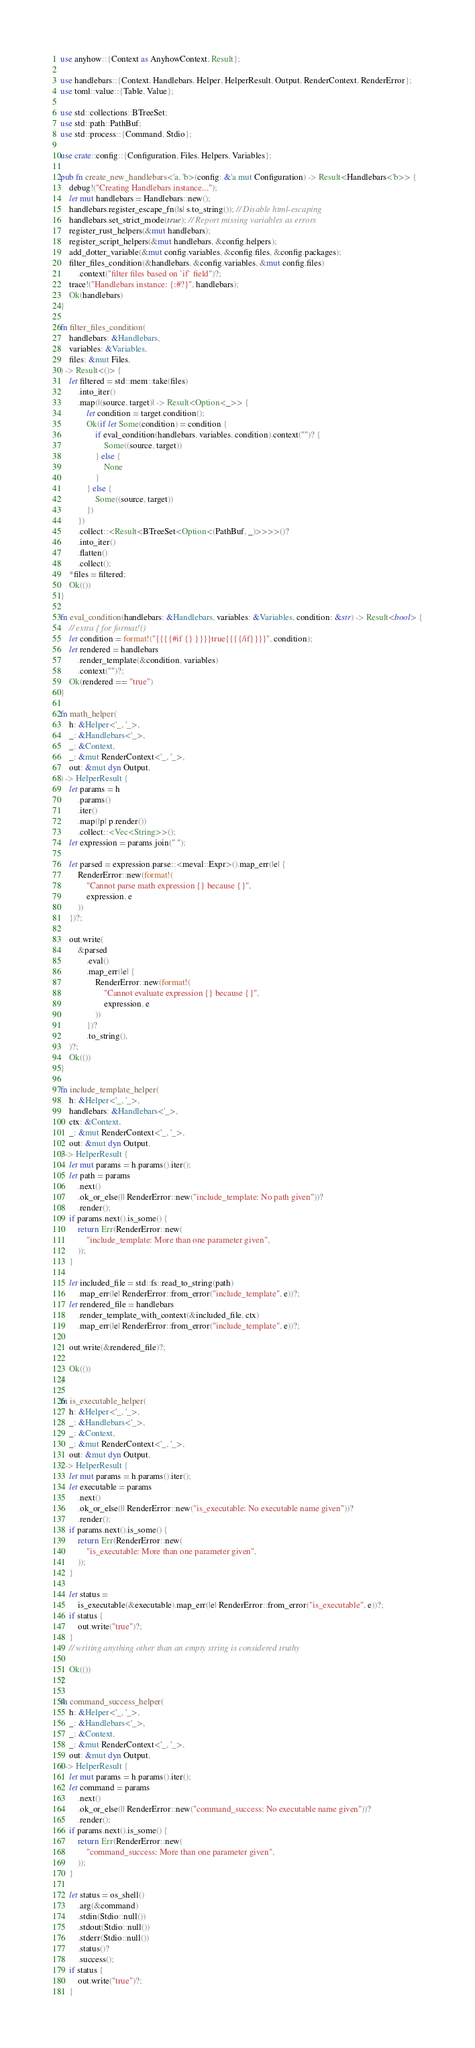<code> <loc_0><loc_0><loc_500><loc_500><_Rust_>use anyhow::{Context as AnyhowContext, Result};

use handlebars::{Context, Handlebars, Helper, HelperResult, Output, RenderContext, RenderError};
use toml::value::{Table, Value};

use std::collections::BTreeSet;
use std::path::PathBuf;
use std::process::{Command, Stdio};

use crate::config::{Configuration, Files, Helpers, Variables};

pub fn create_new_handlebars<'a, 'b>(config: &'a mut Configuration) -> Result<Handlebars<'b>> {
    debug!("Creating Handlebars instance...");
    let mut handlebars = Handlebars::new();
    handlebars.register_escape_fn(|s| s.to_string()); // Disable html-escaping
    handlebars.set_strict_mode(true); // Report missing variables as errors
    register_rust_helpers(&mut handlebars);
    register_script_helpers(&mut handlebars, &config.helpers);
    add_dotter_variable(&mut config.variables, &config.files, &config.packages);
    filter_files_condition(&handlebars, &config.variables, &mut config.files)
        .context("filter files based on `if` field")?;
    trace!("Handlebars instance: {:#?}", handlebars);
    Ok(handlebars)
}

fn filter_files_condition(
    handlebars: &Handlebars,
    variables: &Variables,
    files: &mut Files,
) -> Result<()> {
    let filtered = std::mem::take(files)
        .into_iter()
        .map(|(source, target)| -> Result<Option<_>> {
            let condition = target.condition();
            Ok(if let Some(condition) = condition {
                if eval_condition(handlebars, variables, condition).context("")? {
                    Some((source, target))
                } else {
                    None
                }
            } else {
                Some((source, target))
            })
        })
        .collect::<Result<BTreeSet<Option<(PathBuf, _)>>>>()?
        .into_iter()
        .flatten()
        .collect();
    *files = filtered;
    Ok(())
}

fn eval_condition(handlebars: &Handlebars, variables: &Variables, condition: &str) -> Result<bool> {
    // extra { for format!()
    let condition = format!("{{{{#if {} }}}}true{{{{/if}}}}", condition);
    let rendered = handlebars
        .render_template(&condition, variables)
        .context("")?;
    Ok(rendered == "true")
}

fn math_helper(
    h: &Helper<'_, '_>,
    _: &Handlebars<'_>,
    _: &Context,
    _: &mut RenderContext<'_, '_>,
    out: &mut dyn Output,
) -> HelperResult {
    let params = h
        .params()
        .iter()
        .map(|p| p.render())
        .collect::<Vec<String>>();
    let expression = params.join(" ");

    let parsed = expression.parse::<meval::Expr>().map_err(|e| {
        RenderError::new(format!(
            "Cannot parse math expression {} because {}",
            expression, e
        ))
    })?;

    out.write(
        &parsed
            .eval()
            .map_err(|e| {
                RenderError::new(format!(
                    "Cannot evaluate expression {} because {}",
                    expression, e
                ))
            })?
            .to_string(),
    )?;
    Ok(())
}

fn include_template_helper(
    h: &Helper<'_, '_>,
    handlebars: &Handlebars<'_>,
    ctx: &Context,
    _: &mut RenderContext<'_, '_>,
    out: &mut dyn Output,
) -> HelperResult {
    let mut params = h.params().iter();
    let path = params
        .next()
        .ok_or_else(|| RenderError::new("include_template: No path given"))?
        .render();
    if params.next().is_some() {
        return Err(RenderError::new(
            "include_template: More than one parameter given",
        ));
    }

    let included_file = std::fs::read_to_string(path)
        .map_err(|e| RenderError::from_error("include_template", e))?;
    let rendered_file = handlebars
        .render_template_with_context(&included_file, ctx)
        .map_err(|e| RenderError::from_error("include_template", e))?;

    out.write(&rendered_file)?;

    Ok(())
}

fn is_executable_helper(
    h: &Helper<'_, '_>,
    _: &Handlebars<'_>,
    _: &Context,
    _: &mut RenderContext<'_, '_>,
    out: &mut dyn Output,
) -> HelperResult {
    let mut params = h.params().iter();
    let executable = params
        .next()
        .ok_or_else(|| RenderError::new("is_executable: No executable name given"))?
        .render();
    if params.next().is_some() {
        return Err(RenderError::new(
            "is_executable: More than one parameter given",
        ));
    }

    let status =
        is_executable(&executable).map_err(|e| RenderError::from_error("is_executable", e))?;
    if status {
        out.write("true")?;
    }
    // writing anything other than an empty string is considered truthy

    Ok(())
}

fn command_success_helper(
    h: &Helper<'_, '_>,
    _: &Handlebars<'_>,
    _: &Context,
    _: &mut RenderContext<'_, '_>,
    out: &mut dyn Output,
) -> HelperResult {
    let mut params = h.params().iter();
    let command = params
        .next()
        .ok_or_else(|| RenderError::new("command_success: No executable name given"))?
        .render();
    if params.next().is_some() {
        return Err(RenderError::new(
            "command_success: More than one parameter given",
        ));
    }

    let status = os_shell()
        .arg(&command)
        .stdin(Stdio::null())
        .stdout(Stdio::null())
        .stderr(Stdio::null())
        .status()?
        .success();
    if status {
        out.write("true")?;
    }</code> 